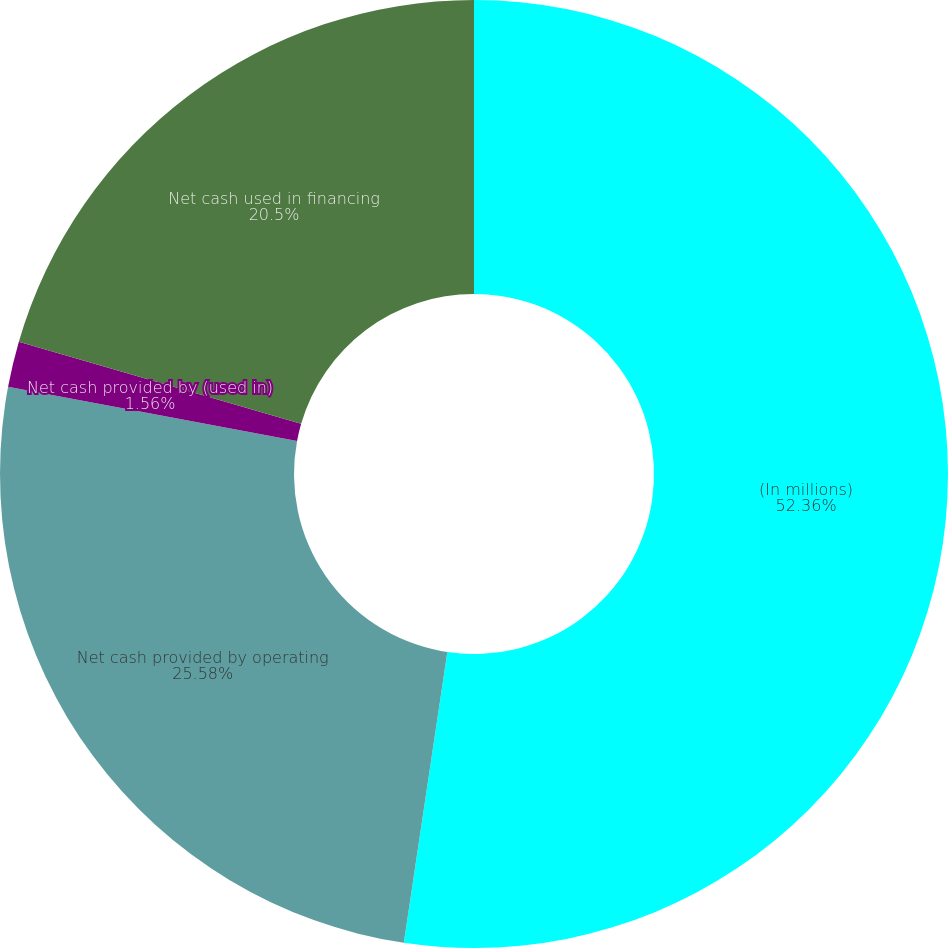Convert chart. <chart><loc_0><loc_0><loc_500><loc_500><pie_chart><fcel>(In millions)<fcel>Net cash provided by operating<fcel>Net cash provided by (used in)<fcel>Net cash used in financing<nl><fcel>52.37%<fcel>25.58%<fcel>1.56%<fcel>20.5%<nl></chart> 